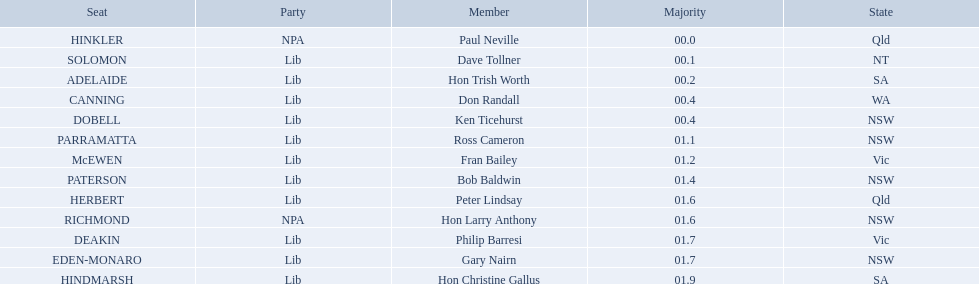Which seats are represented in the electoral system of australia? HINKLER, SOLOMON, ADELAIDE, CANNING, DOBELL, PARRAMATTA, McEWEN, PATERSON, HERBERT, RICHMOND, DEAKIN, EDEN-MONARO, HINDMARSH. What were their majority numbers of both hindmarsh and hinkler? HINKLER, HINDMARSH. Of those two seats, what is the difference in voting majority? 01.9. 